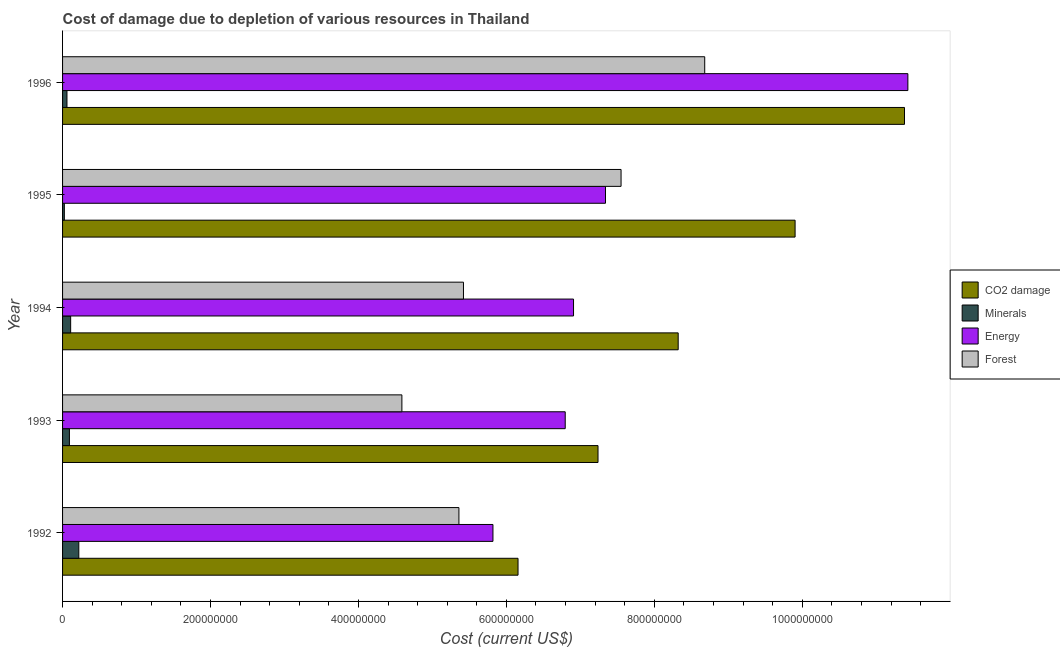How many groups of bars are there?
Provide a short and direct response. 5. What is the label of the 4th group of bars from the top?
Give a very brief answer. 1993. What is the cost of damage due to depletion of forests in 1992?
Your answer should be very brief. 5.36e+08. Across all years, what is the maximum cost of damage due to depletion of coal?
Provide a succinct answer. 1.14e+09. Across all years, what is the minimum cost of damage due to depletion of coal?
Make the answer very short. 6.16e+08. In which year was the cost of damage due to depletion of forests maximum?
Offer a terse response. 1996. In which year was the cost of damage due to depletion of minerals minimum?
Offer a terse response. 1995. What is the total cost of damage due to depletion of minerals in the graph?
Your answer should be compact. 5.05e+07. What is the difference between the cost of damage due to depletion of coal in 1994 and that in 1995?
Keep it short and to the point. -1.58e+08. What is the difference between the cost of damage due to depletion of forests in 1995 and the cost of damage due to depletion of coal in 1996?
Your answer should be very brief. -3.83e+08. What is the average cost of damage due to depletion of minerals per year?
Your answer should be very brief. 1.01e+07. In the year 1994, what is the difference between the cost of damage due to depletion of energy and cost of damage due to depletion of minerals?
Offer a very short reply. 6.80e+08. In how many years, is the cost of damage due to depletion of minerals greater than 440000000 US$?
Your answer should be compact. 0. What is the ratio of the cost of damage due to depletion of forests in 1992 to that in 1995?
Give a very brief answer. 0.71. Is the difference between the cost of damage due to depletion of coal in 1993 and 1995 greater than the difference between the cost of damage due to depletion of forests in 1993 and 1995?
Give a very brief answer. Yes. What is the difference between the highest and the second highest cost of damage due to depletion of coal?
Offer a terse response. 1.48e+08. What is the difference between the highest and the lowest cost of damage due to depletion of coal?
Ensure brevity in your answer.  5.22e+08. Is the sum of the cost of damage due to depletion of energy in 1992 and 1994 greater than the maximum cost of damage due to depletion of coal across all years?
Ensure brevity in your answer.  Yes. What does the 1st bar from the top in 1993 represents?
Your answer should be compact. Forest. What does the 2nd bar from the bottom in 1996 represents?
Your response must be concise. Minerals. Is it the case that in every year, the sum of the cost of damage due to depletion of coal and cost of damage due to depletion of minerals is greater than the cost of damage due to depletion of energy?
Provide a succinct answer. Yes. How many bars are there?
Offer a very short reply. 20. Are all the bars in the graph horizontal?
Offer a terse response. Yes. What is the difference between two consecutive major ticks on the X-axis?
Provide a succinct answer. 2.00e+08. How many legend labels are there?
Provide a succinct answer. 4. How are the legend labels stacked?
Offer a very short reply. Vertical. What is the title of the graph?
Your answer should be compact. Cost of damage due to depletion of various resources in Thailand . Does "Oil" appear as one of the legend labels in the graph?
Offer a terse response. No. What is the label or title of the X-axis?
Your answer should be very brief. Cost (current US$). What is the label or title of the Y-axis?
Your answer should be compact. Year. What is the Cost (current US$) of CO2 damage in 1992?
Your answer should be very brief. 6.16e+08. What is the Cost (current US$) of Minerals in 1992?
Offer a terse response. 2.20e+07. What is the Cost (current US$) in Energy in 1992?
Provide a short and direct response. 5.82e+08. What is the Cost (current US$) of Forest in 1992?
Keep it short and to the point. 5.36e+08. What is the Cost (current US$) of CO2 damage in 1993?
Make the answer very short. 7.24e+08. What is the Cost (current US$) in Minerals in 1993?
Your response must be concise. 9.28e+06. What is the Cost (current US$) in Energy in 1993?
Keep it short and to the point. 6.80e+08. What is the Cost (current US$) in Forest in 1993?
Your answer should be compact. 4.59e+08. What is the Cost (current US$) in CO2 damage in 1994?
Provide a short and direct response. 8.32e+08. What is the Cost (current US$) of Minerals in 1994?
Make the answer very short. 1.09e+07. What is the Cost (current US$) of Energy in 1994?
Offer a terse response. 6.91e+08. What is the Cost (current US$) in Forest in 1994?
Your answer should be very brief. 5.42e+08. What is the Cost (current US$) in CO2 damage in 1995?
Offer a very short reply. 9.90e+08. What is the Cost (current US$) in Minerals in 1995?
Provide a short and direct response. 2.41e+06. What is the Cost (current US$) in Energy in 1995?
Offer a very short reply. 7.34e+08. What is the Cost (current US$) of Forest in 1995?
Ensure brevity in your answer.  7.55e+08. What is the Cost (current US$) of CO2 damage in 1996?
Offer a very short reply. 1.14e+09. What is the Cost (current US$) in Minerals in 1996?
Your answer should be very brief. 5.95e+06. What is the Cost (current US$) of Energy in 1996?
Ensure brevity in your answer.  1.14e+09. What is the Cost (current US$) in Forest in 1996?
Your answer should be very brief. 8.68e+08. Across all years, what is the maximum Cost (current US$) of CO2 damage?
Your answer should be compact. 1.14e+09. Across all years, what is the maximum Cost (current US$) of Minerals?
Offer a very short reply. 2.20e+07. Across all years, what is the maximum Cost (current US$) in Energy?
Offer a very short reply. 1.14e+09. Across all years, what is the maximum Cost (current US$) in Forest?
Your answer should be compact. 8.68e+08. Across all years, what is the minimum Cost (current US$) of CO2 damage?
Your answer should be compact. 6.16e+08. Across all years, what is the minimum Cost (current US$) in Minerals?
Make the answer very short. 2.41e+06. Across all years, what is the minimum Cost (current US$) in Energy?
Your answer should be very brief. 5.82e+08. Across all years, what is the minimum Cost (current US$) of Forest?
Offer a terse response. 4.59e+08. What is the total Cost (current US$) in CO2 damage in the graph?
Provide a succinct answer. 4.30e+09. What is the total Cost (current US$) in Minerals in the graph?
Ensure brevity in your answer.  5.05e+07. What is the total Cost (current US$) of Energy in the graph?
Your answer should be very brief. 3.83e+09. What is the total Cost (current US$) in Forest in the graph?
Provide a short and direct response. 3.16e+09. What is the difference between the Cost (current US$) in CO2 damage in 1992 and that in 1993?
Ensure brevity in your answer.  -1.08e+08. What is the difference between the Cost (current US$) in Minerals in 1992 and that in 1993?
Provide a short and direct response. 1.27e+07. What is the difference between the Cost (current US$) in Energy in 1992 and that in 1993?
Keep it short and to the point. -9.77e+07. What is the difference between the Cost (current US$) in Forest in 1992 and that in 1993?
Offer a very short reply. 7.71e+07. What is the difference between the Cost (current US$) of CO2 damage in 1992 and that in 1994?
Provide a short and direct response. -2.17e+08. What is the difference between the Cost (current US$) in Minerals in 1992 and that in 1994?
Keep it short and to the point. 1.10e+07. What is the difference between the Cost (current US$) of Energy in 1992 and that in 1994?
Provide a short and direct response. -1.09e+08. What is the difference between the Cost (current US$) in Forest in 1992 and that in 1994?
Your answer should be very brief. -6.16e+06. What is the difference between the Cost (current US$) of CO2 damage in 1992 and that in 1995?
Provide a succinct answer. -3.75e+08. What is the difference between the Cost (current US$) of Minerals in 1992 and that in 1995?
Your response must be concise. 1.96e+07. What is the difference between the Cost (current US$) in Energy in 1992 and that in 1995?
Give a very brief answer. -1.52e+08. What is the difference between the Cost (current US$) of Forest in 1992 and that in 1995?
Provide a succinct answer. -2.19e+08. What is the difference between the Cost (current US$) in CO2 damage in 1992 and that in 1996?
Your response must be concise. -5.22e+08. What is the difference between the Cost (current US$) of Minerals in 1992 and that in 1996?
Your answer should be very brief. 1.60e+07. What is the difference between the Cost (current US$) in Energy in 1992 and that in 1996?
Your response must be concise. -5.61e+08. What is the difference between the Cost (current US$) in Forest in 1992 and that in 1996?
Your response must be concise. -3.32e+08. What is the difference between the Cost (current US$) in CO2 damage in 1993 and that in 1994?
Ensure brevity in your answer.  -1.08e+08. What is the difference between the Cost (current US$) in Minerals in 1993 and that in 1994?
Provide a succinct answer. -1.66e+06. What is the difference between the Cost (current US$) in Energy in 1993 and that in 1994?
Your answer should be very brief. -1.12e+07. What is the difference between the Cost (current US$) in Forest in 1993 and that in 1994?
Your response must be concise. -8.33e+07. What is the difference between the Cost (current US$) in CO2 damage in 1993 and that in 1995?
Your answer should be compact. -2.66e+08. What is the difference between the Cost (current US$) of Minerals in 1993 and that in 1995?
Your answer should be very brief. 6.86e+06. What is the difference between the Cost (current US$) of Energy in 1993 and that in 1995?
Provide a succinct answer. -5.45e+07. What is the difference between the Cost (current US$) in Forest in 1993 and that in 1995?
Ensure brevity in your answer.  -2.96e+08. What is the difference between the Cost (current US$) in CO2 damage in 1993 and that in 1996?
Your answer should be compact. -4.14e+08. What is the difference between the Cost (current US$) in Minerals in 1993 and that in 1996?
Your response must be concise. 3.32e+06. What is the difference between the Cost (current US$) of Energy in 1993 and that in 1996?
Offer a very short reply. -4.63e+08. What is the difference between the Cost (current US$) in Forest in 1993 and that in 1996?
Your response must be concise. -4.09e+08. What is the difference between the Cost (current US$) in CO2 damage in 1994 and that in 1995?
Offer a very short reply. -1.58e+08. What is the difference between the Cost (current US$) in Minerals in 1994 and that in 1995?
Your answer should be very brief. 8.52e+06. What is the difference between the Cost (current US$) in Energy in 1994 and that in 1995?
Offer a terse response. -4.32e+07. What is the difference between the Cost (current US$) in Forest in 1994 and that in 1995?
Your response must be concise. -2.13e+08. What is the difference between the Cost (current US$) in CO2 damage in 1994 and that in 1996?
Offer a terse response. -3.06e+08. What is the difference between the Cost (current US$) in Minerals in 1994 and that in 1996?
Provide a short and direct response. 4.98e+06. What is the difference between the Cost (current US$) of Energy in 1994 and that in 1996?
Your answer should be compact. -4.52e+08. What is the difference between the Cost (current US$) in Forest in 1994 and that in 1996?
Ensure brevity in your answer.  -3.26e+08. What is the difference between the Cost (current US$) of CO2 damage in 1995 and that in 1996?
Provide a succinct answer. -1.48e+08. What is the difference between the Cost (current US$) of Minerals in 1995 and that in 1996?
Provide a short and direct response. -3.54e+06. What is the difference between the Cost (current US$) in Energy in 1995 and that in 1996?
Provide a succinct answer. -4.09e+08. What is the difference between the Cost (current US$) of Forest in 1995 and that in 1996?
Your response must be concise. -1.13e+08. What is the difference between the Cost (current US$) in CO2 damage in 1992 and the Cost (current US$) in Minerals in 1993?
Offer a terse response. 6.06e+08. What is the difference between the Cost (current US$) of CO2 damage in 1992 and the Cost (current US$) of Energy in 1993?
Provide a short and direct response. -6.38e+07. What is the difference between the Cost (current US$) of CO2 damage in 1992 and the Cost (current US$) of Forest in 1993?
Provide a succinct answer. 1.57e+08. What is the difference between the Cost (current US$) of Minerals in 1992 and the Cost (current US$) of Energy in 1993?
Keep it short and to the point. -6.58e+08. What is the difference between the Cost (current US$) of Minerals in 1992 and the Cost (current US$) of Forest in 1993?
Ensure brevity in your answer.  -4.37e+08. What is the difference between the Cost (current US$) of Energy in 1992 and the Cost (current US$) of Forest in 1993?
Provide a short and direct response. 1.23e+08. What is the difference between the Cost (current US$) of CO2 damage in 1992 and the Cost (current US$) of Minerals in 1994?
Ensure brevity in your answer.  6.05e+08. What is the difference between the Cost (current US$) in CO2 damage in 1992 and the Cost (current US$) in Energy in 1994?
Your answer should be very brief. -7.50e+07. What is the difference between the Cost (current US$) in CO2 damage in 1992 and the Cost (current US$) in Forest in 1994?
Keep it short and to the point. 7.38e+07. What is the difference between the Cost (current US$) of Minerals in 1992 and the Cost (current US$) of Energy in 1994?
Your answer should be compact. -6.69e+08. What is the difference between the Cost (current US$) in Minerals in 1992 and the Cost (current US$) in Forest in 1994?
Make the answer very short. -5.20e+08. What is the difference between the Cost (current US$) of Energy in 1992 and the Cost (current US$) of Forest in 1994?
Your response must be concise. 3.99e+07. What is the difference between the Cost (current US$) of CO2 damage in 1992 and the Cost (current US$) of Minerals in 1995?
Your answer should be compact. 6.13e+08. What is the difference between the Cost (current US$) of CO2 damage in 1992 and the Cost (current US$) of Energy in 1995?
Provide a succinct answer. -1.18e+08. What is the difference between the Cost (current US$) of CO2 damage in 1992 and the Cost (current US$) of Forest in 1995?
Offer a terse response. -1.39e+08. What is the difference between the Cost (current US$) in Minerals in 1992 and the Cost (current US$) in Energy in 1995?
Give a very brief answer. -7.12e+08. What is the difference between the Cost (current US$) in Minerals in 1992 and the Cost (current US$) in Forest in 1995?
Keep it short and to the point. -7.33e+08. What is the difference between the Cost (current US$) of Energy in 1992 and the Cost (current US$) of Forest in 1995?
Your answer should be compact. -1.73e+08. What is the difference between the Cost (current US$) of CO2 damage in 1992 and the Cost (current US$) of Minerals in 1996?
Ensure brevity in your answer.  6.10e+08. What is the difference between the Cost (current US$) of CO2 damage in 1992 and the Cost (current US$) of Energy in 1996?
Provide a short and direct response. -5.27e+08. What is the difference between the Cost (current US$) in CO2 damage in 1992 and the Cost (current US$) in Forest in 1996?
Give a very brief answer. -2.52e+08. What is the difference between the Cost (current US$) of Minerals in 1992 and the Cost (current US$) of Energy in 1996?
Ensure brevity in your answer.  -1.12e+09. What is the difference between the Cost (current US$) in Minerals in 1992 and the Cost (current US$) in Forest in 1996?
Offer a terse response. -8.46e+08. What is the difference between the Cost (current US$) of Energy in 1992 and the Cost (current US$) of Forest in 1996?
Offer a terse response. -2.86e+08. What is the difference between the Cost (current US$) in CO2 damage in 1993 and the Cost (current US$) in Minerals in 1994?
Keep it short and to the point. 7.13e+08. What is the difference between the Cost (current US$) in CO2 damage in 1993 and the Cost (current US$) in Energy in 1994?
Ensure brevity in your answer.  3.31e+07. What is the difference between the Cost (current US$) of CO2 damage in 1993 and the Cost (current US$) of Forest in 1994?
Your answer should be very brief. 1.82e+08. What is the difference between the Cost (current US$) in Minerals in 1993 and the Cost (current US$) in Energy in 1994?
Ensure brevity in your answer.  -6.82e+08. What is the difference between the Cost (current US$) of Minerals in 1993 and the Cost (current US$) of Forest in 1994?
Make the answer very short. -5.33e+08. What is the difference between the Cost (current US$) in Energy in 1993 and the Cost (current US$) in Forest in 1994?
Provide a short and direct response. 1.38e+08. What is the difference between the Cost (current US$) in CO2 damage in 1993 and the Cost (current US$) in Minerals in 1995?
Your response must be concise. 7.21e+08. What is the difference between the Cost (current US$) of CO2 damage in 1993 and the Cost (current US$) of Energy in 1995?
Provide a short and direct response. -1.01e+07. What is the difference between the Cost (current US$) in CO2 damage in 1993 and the Cost (current US$) in Forest in 1995?
Your response must be concise. -3.11e+07. What is the difference between the Cost (current US$) in Minerals in 1993 and the Cost (current US$) in Energy in 1995?
Keep it short and to the point. -7.25e+08. What is the difference between the Cost (current US$) in Minerals in 1993 and the Cost (current US$) in Forest in 1995?
Provide a succinct answer. -7.46e+08. What is the difference between the Cost (current US$) in Energy in 1993 and the Cost (current US$) in Forest in 1995?
Ensure brevity in your answer.  -7.55e+07. What is the difference between the Cost (current US$) in CO2 damage in 1993 and the Cost (current US$) in Minerals in 1996?
Ensure brevity in your answer.  7.18e+08. What is the difference between the Cost (current US$) of CO2 damage in 1993 and the Cost (current US$) of Energy in 1996?
Keep it short and to the point. -4.19e+08. What is the difference between the Cost (current US$) in CO2 damage in 1993 and the Cost (current US$) in Forest in 1996?
Provide a short and direct response. -1.44e+08. What is the difference between the Cost (current US$) in Minerals in 1993 and the Cost (current US$) in Energy in 1996?
Offer a very short reply. -1.13e+09. What is the difference between the Cost (current US$) in Minerals in 1993 and the Cost (current US$) in Forest in 1996?
Your response must be concise. -8.59e+08. What is the difference between the Cost (current US$) of Energy in 1993 and the Cost (current US$) of Forest in 1996?
Provide a short and direct response. -1.89e+08. What is the difference between the Cost (current US$) of CO2 damage in 1994 and the Cost (current US$) of Minerals in 1995?
Give a very brief answer. 8.30e+08. What is the difference between the Cost (current US$) in CO2 damage in 1994 and the Cost (current US$) in Energy in 1995?
Offer a very short reply. 9.83e+07. What is the difference between the Cost (current US$) in CO2 damage in 1994 and the Cost (current US$) in Forest in 1995?
Your answer should be compact. 7.73e+07. What is the difference between the Cost (current US$) of Minerals in 1994 and the Cost (current US$) of Energy in 1995?
Give a very brief answer. -7.23e+08. What is the difference between the Cost (current US$) in Minerals in 1994 and the Cost (current US$) in Forest in 1995?
Ensure brevity in your answer.  -7.44e+08. What is the difference between the Cost (current US$) of Energy in 1994 and the Cost (current US$) of Forest in 1995?
Your answer should be very brief. -6.43e+07. What is the difference between the Cost (current US$) in CO2 damage in 1994 and the Cost (current US$) in Minerals in 1996?
Your response must be concise. 8.26e+08. What is the difference between the Cost (current US$) of CO2 damage in 1994 and the Cost (current US$) of Energy in 1996?
Give a very brief answer. -3.11e+08. What is the difference between the Cost (current US$) of CO2 damage in 1994 and the Cost (current US$) of Forest in 1996?
Offer a terse response. -3.59e+07. What is the difference between the Cost (current US$) in Minerals in 1994 and the Cost (current US$) in Energy in 1996?
Provide a succinct answer. -1.13e+09. What is the difference between the Cost (current US$) in Minerals in 1994 and the Cost (current US$) in Forest in 1996?
Give a very brief answer. -8.57e+08. What is the difference between the Cost (current US$) in Energy in 1994 and the Cost (current US$) in Forest in 1996?
Keep it short and to the point. -1.77e+08. What is the difference between the Cost (current US$) of CO2 damage in 1995 and the Cost (current US$) of Minerals in 1996?
Provide a short and direct response. 9.84e+08. What is the difference between the Cost (current US$) of CO2 damage in 1995 and the Cost (current US$) of Energy in 1996?
Ensure brevity in your answer.  -1.52e+08. What is the difference between the Cost (current US$) in CO2 damage in 1995 and the Cost (current US$) in Forest in 1996?
Provide a succinct answer. 1.22e+08. What is the difference between the Cost (current US$) of Minerals in 1995 and the Cost (current US$) of Energy in 1996?
Offer a terse response. -1.14e+09. What is the difference between the Cost (current US$) of Minerals in 1995 and the Cost (current US$) of Forest in 1996?
Offer a very short reply. -8.66e+08. What is the difference between the Cost (current US$) of Energy in 1995 and the Cost (current US$) of Forest in 1996?
Provide a short and direct response. -1.34e+08. What is the average Cost (current US$) of CO2 damage per year?
Provide a succinct answer. 8.60e+08. What is the average Cost (current US$) in Minerals per year?
Offer a very short reply. 1.01e+07. What is the average Cost (current US$) in Energy per year?
Your response must be concise. 7.66e+08. What is the average Cost (current US$) of Forest per year?
Provide a short and direct response. 6.32e+08. In the year 1992, what is the difference between the Cost (current US$) in CO2 damage and Cost (current US$) in Minerals?
Your response must be concise. 5.94e+08. In the year 1992, what is the difference between the Cost (current US$) in CO2 damage and Cost (current US$) in Energy?
Ensure brevity in your answer.  3.39e+07. In the year 1992, what is the difference between the Cost (current US$) in CO2 damage and Cost (current US$) in Forest?
Offer a very short reply. 7.99e+07. In the year 1992, what is the difference between the Cost (current US$) of Minerals and Cost (current US$) of Energy?
Offer a very short reply. -5.60e+08. In the year 1992, what is the difference between the Cost (current US$) in Minerals and Cost (current US$) in Forest?
Offer a very short reply. -5.14e+08. In the year 1992, what is the difference between the Cost (current US$) in Energy and Cost (current US$) in Forest?
Your answer should be very brief. 4.60e+07. In the year 1993, what is the difference between the Cost (current US$) in CO2 damage and Cost (current US$) in Minerals?
Ensure brevity in your answer.  7.15e+08. In the year 1993, what is the difference between the Cost (current US$) of CO2 damage and Cost (current US$) of Energy?
Keep it short and to the point. 4.44e+07. In the year 1993, what is the difference between the Cost (current US$) of CO2 damage and Cost (current US$) of Forest?
Your answer should be very brief. 2.65e+08. In the year 1993, what is the difference between the Cost (current US$) in Minerals and Cost (current US$) in Energy?
Offer a very short reply. -6.70e+08. In the year 1993, what is the difference between the Cost (current US$) of Minerals and Cost (current US$) of Forest?
Provide a succinct answer. -4.49e+08. In the year 1993, what is the difference between the Cost (current US$) in Energy and Cost (current US$) in Forest?
Make the answer very short. 2.21e+08. In the year 1994, what is the difference between the Cost (current US$) of CO2 damage and Cost (current US$) of Minerals?
Ensure brevity in your answer.  8.21e+08. In the year 1994, what is the difference between the Cost (current US$) in CO2 damage and Cost (current US$) in Energy?
Provide a short and direct response. 1.42e+08. In the year 1994, what is the difference between the Cost (current US$) in CO2 damage and Cost (current US$) in Forest?
Ensure brevity in your answer.  2.90e+08. In the year 1994, what is the difference between the Cost (current US$) in Minerals and Cost (current US$) in Energy?
Give a very brief answer. -6.80e+08. In the year 1994, what is the difference between the Cost (current US$) in Minerals and Cost (current US$) in Forest?
Provide a short and direct response. -5.31e+08. In the year 1994, what is the difference between the Cost (current US$) in Energy and Cost (current US$) in Forest?
Make the answer very short. 1.49e+08. In the year 1995, what is the difference between the Cost (current US$) of CO2 damage and Cost (current US$) of Minerals?
Your answer should be compact. 9.88e+08. In the year 1995, what is the difference between the Cost (current US$) of CO2 damage and Cost (current US$) of Energy?
Ensure brevity in your answer.  2.56e+08. In the year 1995, what is the difference between the Cost (current US$) in CO2 damage and Cost (current US$) in Forest?
Offer a very short reply. 2.35e+08. In the year 1995, what is the difference between the Cost (current US$) of Minerals and Cost (current US$) of Energy?
Provide a succinct answer. -7.32e+08. In the year 1995, what is the difference between the Cost (current US$) in Minerals and Cost (current US$) in Forest?
Give a very brief answer. -7.53e+08. In the year 1995, what is the difference between the Cost (current US$) in Energy and Cost (current US$) in Forest?
Offer a very short reply. -2.10e+07. In the year 1996, what is the difference between the Cost (current US$) in CO2 damage and Cost (current US$) in Minerals?
Ensure brevity in your answer.  1.13e+09. In the year 1996, what is the difference between the Cost (current US$) in CO2 damage and Cost (current US$) in Energy?
Make the answer very short. -4.58e+06. In the year 1996, what is the difference between the Cost (current US$) in CO2 damage and Cost (current US$) in Forest?
Offer a terse response. 2.70e+08. In the year 1996, what is the difference between the Cost (current US$) of Minerals and Cost (current US$) of Energy?
Provide a short and direct response. -1.14e+09. In the year 1996, what is the difference between the Cost (current US$) in Minerals and Cost (current US$) in Forest?
Provide a short and direct response. -8.62e+08. In the year 1996, what is the difference between the Cost (current US$) in Energy and Cost (current US$) in Forest?
Provide a short and direct response. 2.75e+08. What is the ratio of the Cost (current US$) in CO2 damage in 1992 to that in 1993?
Offer a very short reply. 0.85. What is the ratio of the Cost (current US$) in Minerals in 1992 to that in 1993?
Your answer should be compact. 2.37. What is the ratio of the Cost (current US$) in Energy in 1992 to that in 1993?
Keep it short and to the point. 0.86. What is the ratio of the Cost (current US$) of Forest in 1992 to that in 1993?
Give a very brief answer. 1.17. What is the ratio of the Cost (current US$) in CO2 damage in 1992 to that in 1994?
Keep it short and to the point. 0.74. What is the ratio of the Cost (current US$) of Minerals in 1992 to that in 1994?
Provide a short and direct response. 2.01. What is the ratio of the Cost (current US$) in Energy in 1992 to that in 1994?
Provide a succinct answer. 0.84. What is the ratio of the Cost (current US$) in CO2 damage in 1992 to that in 1995?
Your response must be concise. 0.62. What is the ratio of the Cost (current US$) in Minerals in 1992 to that in 1995?
Your answer should be compact. 9.11. What is the ratio of the Cost (current US$) in Energy in 1992 to that in 1995?
Provide a short and direct response. 0.79. What is the ratio of the Cost (current US$) of Forest in 1992 to that in 1995?
Your response must be concise. 0.71. What is the ratio of the Cost (current US$) of CO2 damage in 1992 to that in 1996?
Your answer should be very brief. 0.54. What is the ratio of the Cost (current US$) of Minerals in 1992 to that in 1996?
Your answer should be compact. 3.69. What is the ratio of the Cost (current US$) in Energy in 1992 to that in 1996?
Keep it short and to the point. 0.51. What is the ratio of the Cost (current US$) of Forest in 1992 to that in 1996?
Your answer should be compact. 0.62. What is the ratio of the Cost (current US$) of CO2 damage in 1993 to that in 1994?
Make the answer very short. 0.87. What is the ratio of the Cost (current US$) of Minerals in 1993 to that in 1994?
Provide a succinct answer. 0.85. What is the ratio of the Cost (current US$) in Energy in 1993 to that in 1994?
Make the answer very short. 0.98. What is the ratio of the Cost (current US$) of Forest in 1993 to that in 1994?
Your response must be concise. 0.85. What is the ratio of the Cost (current US$) of CO2 damage in 1993 to that in 1995?
Make the answer very short. 0.73. What is the ratio of the Cost (current US$) of Minerals in 1993 to that in 1995?
Your answer should be very brief. 3.85. What is the ratio of the Cost (current US$) of Energy in 1993 to that in 1995?
Your answer should be compact. 0.93. What is the ratio of the Cost (current US$) of Forest in 1993 to that in 1995?
Offer a very short reply. 0.61. What is the ratio of the Cost (current US$) of CO2 damage in 1993 to that in 1996?
Offer a very short reply. 0.64. What is the ratio of the Cost (current US$) of Minerals in 1993 to that in 1996?
Provide a succinct answer. 1.56. What is the ratio of the Cost (current US$) in Energy in 1993 to that in 1996?
Offer a terse response. 0.59. What is the ratio of the Cost (current US$) in Forest in 1993 to that in 1996?
Provide a succinct answer. 0.53. What is the ratio of the Cost (current US$) of CO2 damage in 1994 to that in 1995?
Offer a very short reply. 0.84. What is the ratio of the Cost (current US$) in Minerals in 1994 to that in 1995?
Keep it short and to the point. 4.53. What is the ratio of the Cost (current US$) in Energy in 1994 to that in 1995?
Your answer should be very brief. 0.94. What is the ratio of the Cost (current US$) of Forest in 1994 to that in 1995?
Offer a terse response. 0.72. What is the ratio of the Cost (current US$) in CO2 damage in 1994 to that in 1996?
Provide a succinct answer. 0.73. What is the ratio of the Cost (current US$) in Minerals in 1994 to that in 1996?
Give a very brief answer. 1.84. What is the ratio of the Cost (current US$) of Energy in 1994 to that in 1996?
Keep it short and to the point. 0.6. What is the ratio of the Cost (current US$) of Forest in 1994 to that in 1996?
Keep it short and to the point. 0.62. What is the ratio of the Cost (current US$) of CO2 damage in 1995 to that in 1996?
Give a very brief answer. 0.87. What is the ratio of the Cost (current US$) in Minerals in 1995 to that in 1996?
Offer a very short reply. 0.41. What is the ratio of the Cost (current US$) of Energy in 1995 to that in 1996?
Provide a succinct answer. 0.64. What is the ratio of the Cost (current US$) in Forest in 1995 to that in 1996?
Provide a short and direct response. 0.87. What is the difference between the highest and the second highest Cost (current US$) of CO2 damage?
Make the answer very short. 1.48e+08. What is the difference between the highest and the second highest Cost (current US$) of Minerals?
Provide a short and direct response. 1.10e+07. What is the difference between the highest and the second highest Cost (current US$) of Energy?
Provide a succinct answer. 4.09e+08. What is the difference between the highest and the second highest Cost (current US$) in Forest?
Keep it short and to the point. 1.13e+08. What is the difference between the highest and the lowest Cost (current US$) of CO2 damage?
Ensure brevity in your answer.  5.22e+08. What is the difference between the highest and the lowest Cost (current US$) in Minerals?
Your answer should be very brief. 1.96e+07. What is the difference between the highest and the lowest Cost (current US$) in Energy?
Keep it short and to the point. 5.61e+08. What is the difference between the highest and the lowest Cost (current US$) in Forest?
Offer a very short reply. 4.09e+08. 